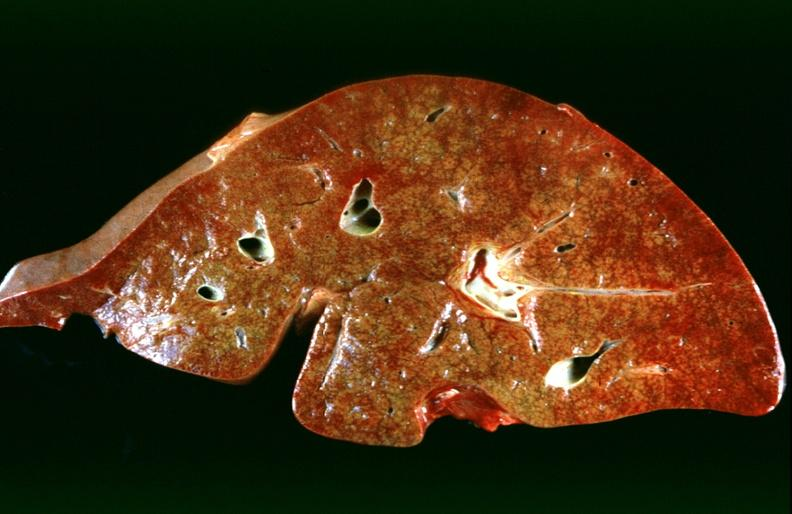s liver present?
Answer the question using a single word or phrase. Yes 